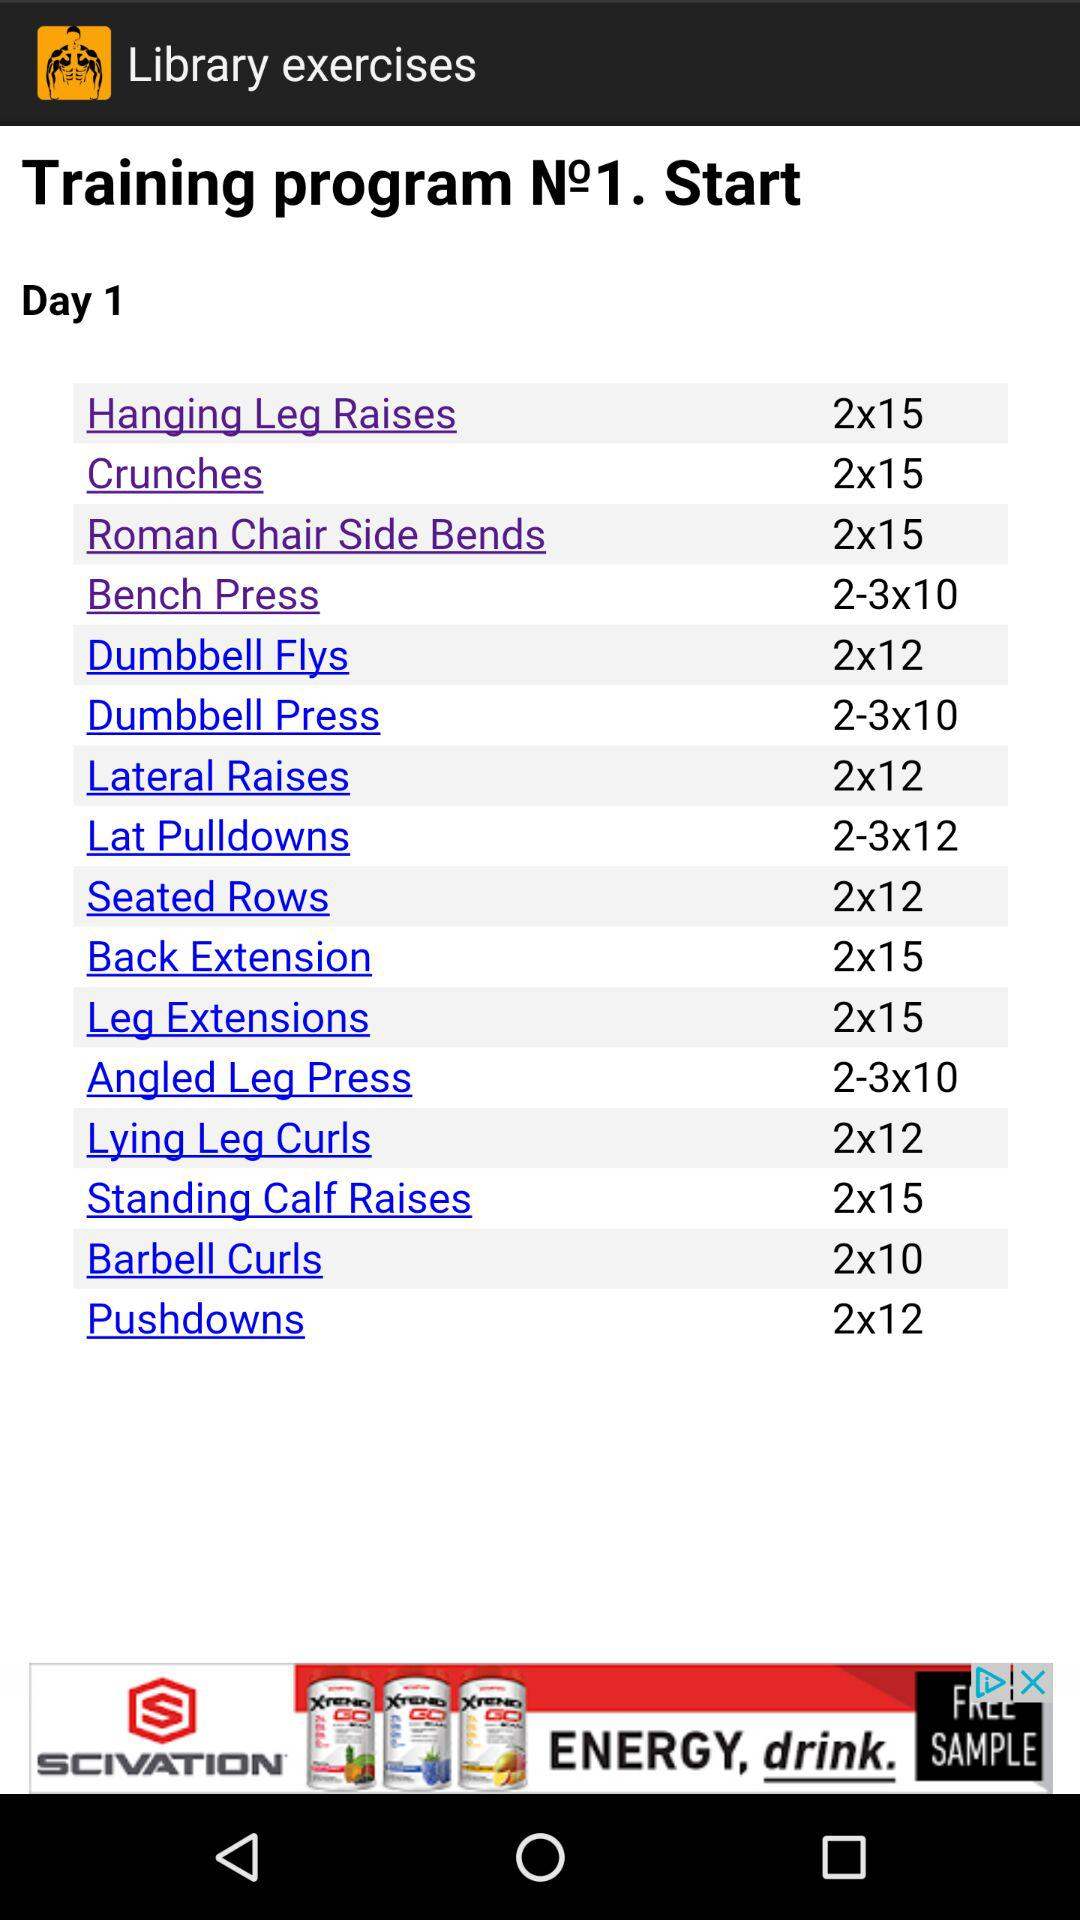What is the number of sets for the angled leg press exercise? The number of sets for the angled leg press exercise is between 2 and 3. 